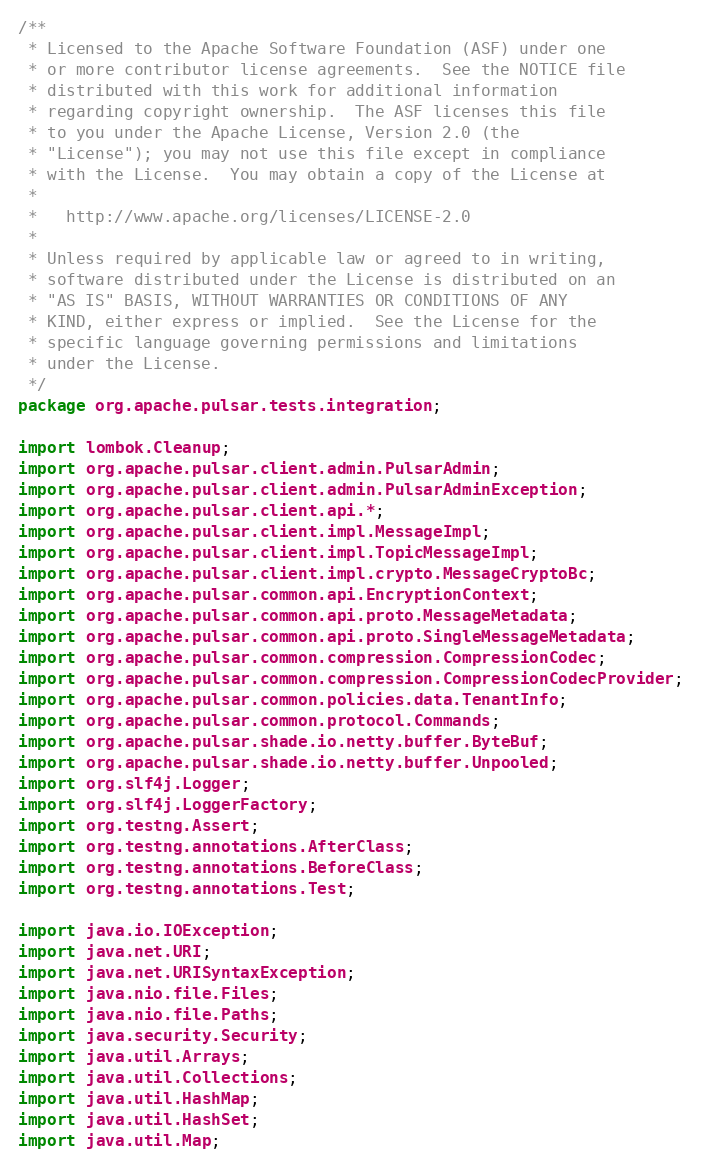Convert code to text. <code><loc_0><loc_0><loc_500><loc_500><_Java_>/**
 * Licensed to the Apache Software Foundation (ASF) under one
 * or more contributor license agreements.  See the NOTICE file
 * distributed with this work for additional information
 * regarding copyright ownership.  The ASF licenses this file
 * to you under the Apache License, Version 2.0 (the
 * "License"); you may not use this file except in compliance
 * with the License.  You may obtain a copy of the License at
 *
 *   http://www.apache.org/licenses/LICENSE-2.0
 *
 * Unless required by applicable law or agreed to in writing,
 * software distributed under the License is distributed on an
 * "AS IS" BASIS, WITHOUT WARRANTIES OR CONDITIONS OF ANY
 * KIND, either express or implied.  See the License for the
 * specific language governing permissions and limitations
 * under the License.
 */
package org.apache.pulsar.tests.integration;

import lombok.Cleanup;
import org.apache.pulsar.client.admin.PulsarAdmin;
import org.apache.pulsar.client.admin.PulsarAdminException;
import org.apache.pulsar.client.api.*;
import org.apache.pulsar.client.impl.MessageImpl;
import org.apache.pulsar.client.impl.TopicMessageImpl;
import org.apache.pulsar.client.impl.crypto.MessageCryptoBc;
import org.apache.pulsar.common.api.EncryptionContext;
import org.apache.pulsar.common.api.proto.MessageMetadata;
import org.apache.pulsar.common.api.proto.SingleMessageMetadata;
import org.apache.pulsar.common.compression.CompressionCodec;
import org.apache.pulsar.common.compression.CompressionCodecProvider;
import org.apache.pulsar.common.policies.data.TenantInfo;
import org.apache.pulsar.common.protocol.Commands;
import org.apache.pulsar.shade.io.netty.buffer.ByteBuf;
import org.apache.pulsar.shade.io.netty.buffer.Unpooled;
import org.slf4j.Logger;
import org.slf4j.LoggerFactory;
import org.testng.Assert;
import org.testng.annotations.AfterClass;
import org.testng.annotations.BeforeClass;
import org.testng.annotations.Test;

import java.io.IOException;
import java.net.URI;
import java.net.URISyntaxException;
import java.nio.file.Files;
import java.nio.file.Paths;
import java.security.Security;
import java.util.Arrays;
import java.util.Collections;
import java.util.HashMap;
import java.util.HashSet;
import java.util.Map;</code> 